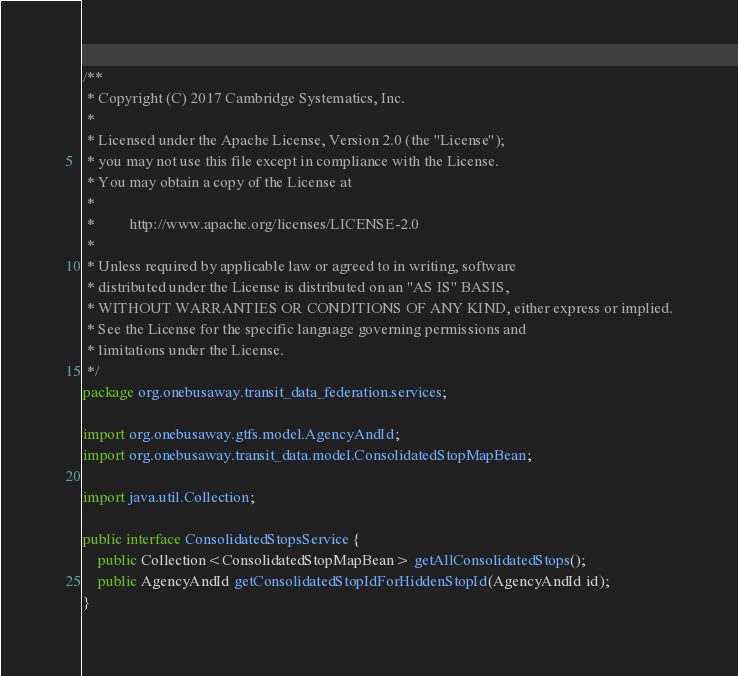Convert code to text. <code><loc_0><loc_0><loc_500><loc_500><_Java_>/**
 * Copyright (C) 2017 Cambridge Systematics, Inc.
 *
 * Licensed under the Apache License, Version 2.0 (the "License");
 * you may not use this file except in compliance with the License.
 * You may obtain a copy of the License at
 *
 *         http://www.apache.org/licenses/LICENSE-2.0
 *
 * Unless required by applicable law or agreed to in writing, software
 * distributed under the License is distributed on an "AS IS" BASIS,
 * WITHOUT WARRANTIES OR CONDITIONS OF ANY KIND, either express or implied.
 * See the License for the specific language governing permissions and
 * limitations under the License.
 */
package org.onebusaway.transit_data_federation.services;

import org.onebusaway.gtfs.model.AgencyAndId;
import org.onebusaway.transit_data.model.ConsolidatedStopMapBean;

import java.util.Collection;

public interface ConsolidatedStopsService {
    public Collection<ConsolidatedStopMapBean> getAllConsolidatedStops();
    public AgencyAndId getConsolidatedStopIdForHiddenStopId(AgencyAndId id);
}
</code> 